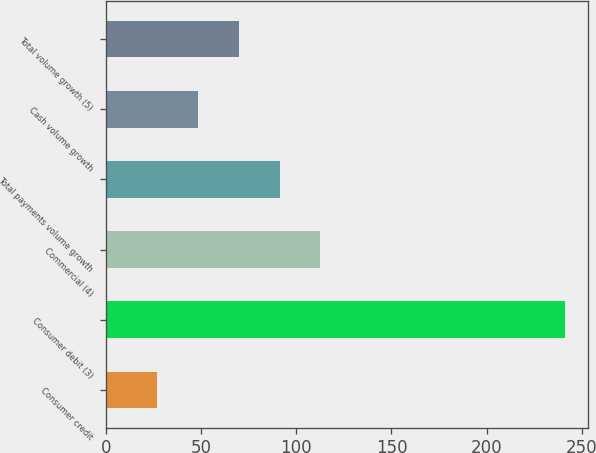Convert chart. <chart><loc_0><loc_0><loc_500><loc_500><bar_chart><fcel>Consumer credit<fcel>Consumer debit (3)<fcel>Commercial (4)<fcel>Total payments volume growth<fcel>Cash volume growth<fcel>Total volume growth (5)<nl><fcel>27<fcel>241<fcel>112.6<fcel>91.2<fcel>48.4<fcel>69.8<nl></chart> 